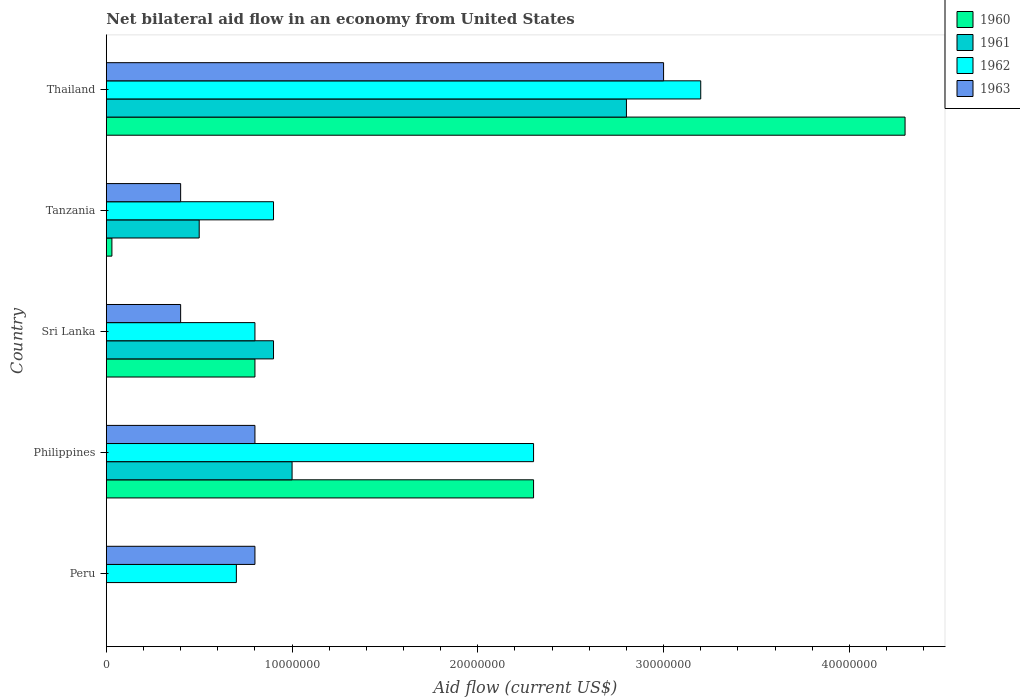How many different coloured bars are there?
Provide a succinct answer. 4. How many groups of bars are there?
Your response must be concise. 5. Are the number of bars per tick equal to the number of legend labels?
Provide a short and direct response. No. How many bars are there on the 4th tick from the top?
Provide a succinct answer. 4. What is the label of the 3rd group of bars from the top?
Ensure brevity in your answer.  Sri Lanka. What is the net bilateral aid flow in 1962 in Thailand?
Give a very brief answer. 3.20e+07. Across all countries, what is the maximum net bilateral aid flow in 1963?
Make the answer very short. 3.00e+07. Across all countries, what is the minimum net bilateral aid flow in 1961?
Provide a succinct answer. 0. In which country was the net bilateral aid flow in 1960 maximum?
Make the answer very short. Thailand. What is the total net bilateral aid flow in 1963 in the graph?
Your answer should be compact. 5.40e+07. What is the difference between the net bilateral aid flow in 1963 in Tanzania and that in Thailand?
Offer a very short reply. -2.60e+07. What is the difference between the net bilateral aid flow in 1962 in Tanzania and the net bilateral aid flow in 1960 in Sri Lanka?
Provide a short and direct response. 1.00e+06. What is the average net bilateral aid flow in 1960 per country?
Give a very brief answer. 1.49e+07. What is the difference between the net bilateral aid flow in 1962 and net bilateral aid flow in 1961 in Philippines?
Keep it short and to the point. 1.30e+07. What is the ratio of the net bilateral aid flow in 1963 in Tanzania to that in Thailand?
Make the answer very short. 0.13. Is the net bilateral aid flow in 1961 in Sri Lanka less than that in Thailand?
Give a very brief answer. Yes. Is the difference between the net bilateral aid flow in 1962 in Philippines and Thailand greater than the difference between the net bilateral aid flow in 1961 in Philippines and Thailand?
Your answer should be compact. Yes. What is the difference between the highest and the second highest net bilateral aid flow in 1961?
Your response must be concise. 1.80e+07. What is the difference between the highest and the lowest net bilateral aid flow in 1962?
Your response must be concise. 2.50e+07. Is it the case that in every country, the sum of the net bilateral aid flow in 1962 and net bilateral aid flow in 1963 is greater than the sum of net bilateral aid flow in 1961 and net bilateral aid flow in 1960?
Your answer should be compact. No. How many bars are there?
Keep it short and to the point. 18. Are all the bars in the graph horizontal?
Your answer should be compact. Yes. How many countries are there in the graph?
Your answer should be compact. 5. What is the difference between two consecutive major ticks on the X-axis?
Offer a terse response. 1.00e+07. Are the values on the major ticks of X-axis written in scientific E-notation?
Provide a short and direct response. No. Where does the legend appear in the graph?
Provide a short and direct response. Top right. How many legend labels are there?
Provide a succinct answer. 4. How are the legend labels stacked?
Offer a very short reply. Vertical. What is the title of the graph?
Provide a short and direct response. Net bilateral aid flow in an economy from United States. What is the label or title of the X-axis?
Your answer should be compact. Aid flow (current US$). What is the label or title of the Y-axis?
Your answer should be very brief. Country. What is the Aid flow (current US$) of 1960 in Peru?
Give a very brief answer. 0. What is the Aid flow (current US$) in 1962 in Peru?
Your answer should be compact. 7.00e+06. What is the Aid flow (current US$) in 1963 in Peru?
Make the answer very short. 8.00e+06. What is the Aid flow (current US$) in 1960 in Philippines?
Offer a terse response. 2.30e+07. What is the Aid flow (current US$) of 1961 in Philippines?
Give a very brief answer. 1.00e+07. What is the Aid flow (current US$) in 1962 in Philippines?
Your response must be concise. 2.30e+07. What is the Aid flow (current US$) in 1961 in Sri Lanka?
Offer a terse response. 9.00e+06. What is the Aid flow (current US$) in 1963 in Sri Lanka?
Provide a succinct answer. 4.00e+06. What is the Aid flow (current US$) of 1960 in Tanzania?
Make the answer very short. 3.00e+05. What is the Aid flow (current US$) of 1962 in Tanzania?
Provide a short and direct response. 9.00e+06. What is the Aid flow (current US$) of 1963 in Tanzania?
Your response must be concise. 4.00e+06. What is the Aid flow (current US$) in 1960 in Thailand?
Keep it short and to the point. 4.30e+07. What is the Aid flow (current US$) of 1961 in Thailand?
Offer a terse response. 2.80e+07. What is the Aid flow (current US$) in 1962 in Thailand?
Ensure brevity in your answer.  3.20e+07. What is the Aid flow (current US$) in 1963 in Thailand?
Your answer should be very brief. 3.00e+07. Across all countries, what is the maximum Aid flow (current US$) in 1960?
Provide a short and direct response. 4.30e+07. Across all countries, what is the maximum Aid flow (current US$) in 1961?
Offer a very short reply. 2.80e+07. Across all countries, what is the maximum Aid flow (current US$) in 1962?
Your answer should be very brief. 3.20e+07. Across all countries, what is the maximum Aid flow (current US$) in 1963?
Offer a very short reply. 3.00e+07. Across all countries, what is the minimum Aid flow (current US$) of 1960?
Your answer should be compact. 0. Across all countries, what is the minimum Aid flow (current US$) in 1961?
Your answer should be very brief. 0. Across all countries, what is the minimum Aid flow (current US$) of 1963?
Ensure brevity in your answer.  4.00e+06. What is the total Aid flow (current US$) in 1960 in the graph?
Make the answer very short. 7.43e+07. What is the total Aid flow (current US$) in 1961 in the graph?
Make the answer very short. 5.20e+07. What is the total Aid flow (current US$) of 1962 in the graph?
Your response must be concise. 7.90e+07. What is the total Aid flow (current US$) of 1963 in the graph?
Ensure brevity in your answer.  5.40e+07. What is the difference between the Aid flow (current US$) in 1962 in Peru and that in Philippines?
Your response must be concise. -1.60e+07. What is the difference between the Aid flow (current US$) of 1963 in Peru and that in Philippines?
Keep it short and to the point. 0. What is the difference between the Aid flow (current US$) in 1962 in Peru and that in Thailand?
Keep it short and to the point. -2.50e+07. What is the difference between the Aid flow (current US$) of 1963 in Peru and that in Thailand?
Provide a short and direct response. -2.20e+07. What is the difference between the Aid flow (current US$) in 1960 in Philippines and that in Sri Lanka?
Offer a very short reply. 1.50e+07. What is the difference between the Aid flow (current US$) of 1962 in Philippines and that in Sri Lanka?
Your answer should be very brief. 1.50e+07. What is the difference between the Aid flow (current US$) in 1963 in Philippines and that in Sri Lanka?
Make the answer very short. 4.00e+06. What is the difference between the Aid flow (current US$) in 1960 in Philippines and that in Tanzania?
Provide a short and direct response. 2.27e+07. What is the difference between the Aid flow (current US$) of 1961 in Philippines and that in Tanzania?
Provide a succinct answer. 5.00e+06. What is the difference between the Aid flow (current US$) in 1962 in Philippines and that in Tanzania?
Keep it short and to the point. 1.40e+07. What is the difference between the Aid flow (current US$) of 1960 in Philippines and that in Thailand?
Offer a very short reply. -2.00e+07. What is the difference between the Aid flow (current US$) in 1961 in Philippines and that in Thailand?
Offer a very short reply. -1.80e+07. What is the difference between the Aid flow (current US$) of 1962 in Philippines and that in Thailand?
Ensure brevity in your answer.  -9.00e+06. What is the difference between the Aid flow (current US$) in 1963 in Philippines and that in Thailand?
Provide a succinct answer. -2.20e+07. What is the difference between the Aid flow (current US$) of 1960 in Sri Lanka and that in Tanzania?
Give a very brief answer. 7.70e+06. What is the difference between the Aid flow (current US$) in 1961 in Sri Lanka and that in Tanzania?
Offer a terse response. 4.00e+06. What is the difference between the Aid flow (current US$) of 1963 in Sri Lanka and that in Tanzania?
Offer a very short reply. 0. What is the difference between the Aid flow (current US$) in 1960 in Sri Lanka and that in Thailand?
Keep it short and to the point. -3.50e+07. What is the difference between the Aid flow (current US$) in 1961 in Sri Lanka and that in Thailand?
Provide a succinct answer. -1.90e+07. What is the difference between the Aid flow (current US$) in 1962 in Sri Lanka and that in Thailand?
Your response must be concise. -2.40e+07. What is the difference between the Aid flow (current US$) in 1963 in Sri Lanka and that in Thailand?
Your answer should be compact. -2.60e+07. What is the difference between the Aid flow (current US$) in 1960 in Tanzania and that in Thailand?
Keep it short and to the point. -4.27e+07. What is the difference between the Aid flow (current US$) in 1961 in Tanzania and that in Thailand?
Provide a short and direct response. -2.30e+07. What is the difference between the Aid flow (current US$) in 1962 in Tanzania and that in Thailand?
Offer a terse response. -2.30e+07. What is the difference between the Aid flow (current US$) of 1963 in Tanzania and that in Thailand?
Make the answer very short. -2.60e+07. What is the difference between the Aid flow (current US$) of 1962 in Peru and the Aid flow (current US$) of 1963 in Philippines?
Ensure brevity in your answer.  -1.00e+06. What is the difference between the Aid flow (current US$) in 1962 in Peru and the Aid flow (current US$) in 1963 in Sri Lanka?
Your answer should be very brief. 3.00e+06. What is the difference between the Aid flow (current US$) in 1962 in Peru and the Aid flow (current US$) in 1963 in Thailand?
Your response must be concise. -2.30e+07. What is the difference between the Aid flow (current US$) in 1960 in Philippines and the Aid flow (current US$) in 1961 in Sri Lanka?
Give a very brief answer. 1.40e+07. What is the difference between the Aid flow (current US$) in 1960 in Philippines and the Aid flow (current US$) in 1962 in Sri Lanka?
Offer a terse response. 1.50e+07. What is the difference between the Aid flow (current US$) in 1960 in Philippines and the Aid flow (current US$) in 1963 in Sri Lanka?
Keep it short and to the point. 1.90e+07. What is the difference between the Aid flow (current US$) of 1961 in Philippines and the Aid flow (current US$) of 1962 in Sri Lanka?
Provide a succinct answer. 2.00e+06. What is the difference between the Aid flow (current US$) of 1962 in Philippines and the Aid flow (current US$) of 1963 in Sri Lanka?
Give a very brief answer. 1.90e+07. What is the difference between the Aid flow (current US$) of 1960 in Philippines and the Aid flow (current US$) of 1961 in Tanzania?
Your answer should be very brief. 1.80e+07. What is the difference between the Aid flow (current US$) of 1960 in Philippines and the Aid flow (current US$) of 1962 in Tanzania?
Your answer should be compact. 1.40e+07. What is the difference between the Aid flow (current US$) of 1960 in Philippines and the Aid flow (current US$) of 1963 in Tanzania?
Ensure brevity in your answer.  1.90e+07. What is the difference between the Aid flow (current US$) of 1961 in Philippines and the Aid flow (current US$) of 1962 in Tanzania?
Your answer should be very brief. 1.00e+06. What is the difference between the Aid flow (current US$) in 1962 in Philippines and the Aid flow (current US$) in 1963 in Tanzania?
Ensure brevity in your answer.  1.90e+07. What is the difference between the Aid flow (current US$) in 1960 in Philippines and the Aid flow (current US$) in 1961 in Thailand?
Make the answer very short. -5.00e+06. What is the difference between the Aid flow (current US$) of 1960 in Philippines and the Aid flow (current US$) of 1962 in Thailand?
Ensure brevity in your answer.  -9.00e+06. What is the difference between the Aid flow (current US$) of 1960 in Philippines and the Aid flow (current US$) of 1963 in Thailand?
Ensure brevity in your answer.  -7.00e+06. What is the difference between the Aid flow (current US$) of 1961 in Philippines and the Aid flow (current US$) of 1962 in Thailand?
Provide a short and direct response. -2.20e+07. What is the difference between the Aid flow (current US$) of 1961 in Philippines and the Aid flow (current US$) of 1963 in Thailand?
Ensure brevity in your answer.  -2.00e+07. What is the difference between the Aid flow (current US$) of 1962 in Philippines and the Aid flow (current US$) of 1963 in Thailand?
Keep it short and to the point. -7.00e+06. What is the difference between the Aid flow (current US$) in 1962 in Sri Lanka and the Aid flow (current US$) in 1963 in Tanzania?
Offer a very short reply. 4.00e+06. What is the difference between the Aid flow (current US$) of 1960 in Sri Lanka and the Aid flow (current US$) of 1961 in Thailand?
Keep it short and to the point. -2.00e+07. What is the difference between the Aid flow (current US$) of 1960 in Sri Lanka and the Aid flow (current US$) of 1962 in Thailand?
Keep it short and to the point. -2.40e+07. What is the difference between the Aid flow (current US$) in 1960 in Sri Lanka and the Aid flow (current US$) in 1963 in Thailand?
Offer a very short reply. -2.20e+07. What is the difference between the Aid flow (current US$) of 1961 in Sri Lanka and the Aid flow (current US$) of 1962 in Thailand?
Provide a succinct answer. -2.30e+07. What is the difference between the Aid flow (current US$) in 1961 in Sri Lanka and the Aid flow (current US$) in 1963 in Thailand?
Your response must be concise. -2.10e+07. What is the difference between the Aid flow (current US$) in 1962 in Sri Lanka and the Aid flow (current US$) in 1963 in Thailand?
Make the answer very short. -2.20e+07. What is the difference between the Aid flow (current US$) in 1960 in Tanzania and the Aid flow (current US$) in 1961 in Thailand?
Give a very brief answer. -2.77e+07. What is the difference between the Aid flow (current US$) in 1960 in Tanzania and the Aid flow (current US$) in 1962 in Thailand?
Provide a short and direct response. -3.17e+07. What is the difference between the Aid flow (current US$) of 1960 in Tanzania and the Aid flow (current US$) of 1963 in Thailand?
Your response must be concise. -2.97e+07. What is the difference between the Aid flow (current US$) of 1961 in Tanzania and the Aid flow (current US$) of 1962 in Thailand?
Make the answer very short. -2.70e+07. What is the difference between the Aid flow (current US$) in 1961 in Tanzania and the Aid flow (current US$) in 1963 in Thailand?
Your response must be concise. -2.50e+07. What is the difference between the Aid flow (current US$) of 1962 in Tanzania and the Aid flow (current US$) of 1963 in Thailand?
Give a very brief answer. -2.10e+07. What is the average Aid flow (current US$) of 1960 per country?
Give a very brief answer. 1.49e+07. What is the average Aid flow (current US$) of 1961 per country?
Offer a very short reply. 1.04e+07. What is the average Aid flow (current US$) in 1962 per country?
Give a very brief answer. 1.58e+07. What is the average Aid flow (current US$) of 1963 per country?
Offer a terse response. 1.08e+07. What is the difference between the Aid flow (current US$) in 1962 and Aid flow (current US$) in 1963 in Peru?
Make the answer very short. -1.00e+06. What is the difference between the Aid flow (current US$) of 1960 and Aid flow (current US$) of 1961 in Philippines?
Provide a short and direct response. 1.30e+07. What is the difference between the Aid flow (current US$) of 1960 and Aid flow (current US$) of 1963 in Philippines?
Give a very brief answer. 1.50e+07. What is the difference between the Aid flow (current US$) in 1961 and Aid flow (current US$) in 1962 in Philippines?
Keep it short and to the point. -1.30e+07. What is the difference between the Aid flow (current US$) of 1961 and Aid flow (current US$) of 1963 in Philippines?
Keep it short and to the point. 2.00e+06. What is the difference between the Aid flow (current US$) of 1962 and Aid flow (current US$) of 1963 in Philippines?
Give a very brief answer. 1.50e+07. What is the difference between the Aid flow (current US$) in 1960 and Aid flow (current US$) in 1961 in Sri Lanka?
Provide a short and direct response. -1.00e+06. What is the difference between the Aid flow (current US$) in 1960 and Aid flow (current US$) in 1962 in Sri Lanka?
Provide a short and direct response. 0. What is the difference between the Aid flow (current US$) of 1960 and Aid flow (current US$) of 1961 in Tanzania?
Ensure brevity in your answer.  -4.70e+06. What is the difference between the Aid flow (current US$) in 1960 and Aid flow (current US$) in 1962 in Tanzania?
Provide a short and direct response. -8.70e+06. What is the difference between the Aid flow (current US$) of 1960 and Aid flow (current US$) of 1963 in Tanzania?
Your response must be concise. -3.70e+06. What is the difference between the Aid flow (current US$) of 1961 and Aid flow (current US$) of 1962 in Tanzania?
Give a very brief answer. -4.00e+06. What is the difference between the Aid flow (current US$) of 1960 and Aid flow (current US$) of 1961 in Thailand?
Your answer should be very brief. 1.50e+07. What is the difference between the Aid flow (current US$) of 1960 and Aid flow (current US$) of 1962 in Thailand?
Keep it short and to the point. 1.10e+07. What is the difference between the Aid flow (current US$) in 1960 and Aid flow (current US$) in 1963 in Thailand?
Give a very brief answer. 1.30e+07. What is the ratio of the Aid flow (current US$) in 1962 in Peru to that in Philippines?
Ensure brevity in your answer.  0.3. What is the ratio of the Aid flow (current US$) in 1963 in Peru to that in Philippines?
Offer a terse response. 1. What is the ratio of the Aid flow (current US$) of 1962 in Peru to that in Sri Lanka?
Provide a succinct answer. 0.88. What is the ratio of the Aid flow (current US$) of 1962 in Peru to that in Tanzania?
Ensure brevity in your answer.  0.78. What is the ratio of the Aid flow (current US$) in 1962 in Peru to that in Thailand?
Provide a succinct answer. 0.22. What is the ratio of the Aid flow (current US$) of 1963 in Peru to that in Thailand?
Offer a very short reply. 0.27. What is the ratio of the Aid flow (current US$) in 1960 in Philippines to that in Sri Lanka?
Provide a succinct answer. 2.88. What is the ratio of the Aid flow (current US$) of 1961 in Philippines to that in Sri Lanka?
Keep it short and to the point. 1.11. What is the ratio of the Aid flow (current US$) in 1962 in Philippines to that in Sri Lanka?
Provide a short and direct response. 2.88. What is the ratio of the Aid flow (current US$) of 1960 in Philippines to that in Tanzania?
Offer a very short reply. 76.67. What is the ratio of the Aid flow (current US$) of 1962 in Philippines to that in Tanzania?
Your answer should be compact. 2.56. What is the ratio of the Aid flow (current US$) in 1963 in Philippines to that in Tanzania?
Offer a terse response. 2. What is the ratio of the Aid flow (current US$) of 1960 in Philippines to that in Thailand?
Keep it short and to the point. 0.53. What is the ratio of the Aid flow (current US$) in 1961 in Philippines to that in Thailand?
Make the answer very short. 0.36. What is the ratio of the Aid flow (current US$) in 1962 in Philippines to that in Thailand?
Offer a terse response. 0.72. What is the ratio of the Aid flow (current US$) in 1963 in Philippines to that in Thailand?
Keep it short and to the point. 0.27. What is the ratio of the Aid flow (current US$) in 1960 in Sri Lanka to that in Tanzania?
Offer a terse response. 26.67. What is the ratio of the Aid flow (current US$) of 1961 in Sri Lanka to that in Tanzania?
Your response must be concise. 1.8. What is the ratio of the Aid flow (current US$) in 1960 in Sri Lanka to that in Thailand?
Provide a short and direct response. 0.19. What is the ratio of the Aid flow (current US$) in 1961 in Sri Lanka to that in Thailand?
Make the answer very short. 0.32. What is the ratio of the Aid flow (current US$) in 1962 in Sri Lanka to that in Thailand?
Your response must be concise. 0.25. What is the ratio of the Aid flow (current US$) in 1963 in Sri Lanka to that in Thailand?
Your answer should be very brief. 0.13. What is the ratio of the Aid flow (current US$) of 1960 in Tanzania to that in Thailand?
Give a very brief answer. 0.01. What is the ratio of the Aid flow (current US$) of 1961 in Tanzania to that in Thailand?
Offer a very short reply. 0.18. What is the ratio of the Aid flow (current US$) of 1962 in Tanzania to that in Thailand?
Offer a very short reply. 0.28. What is the ratio of the Aid flow (current US$) in 1963 in Tanzania to that in Thailand?
Provide a short and direct response. 0.13. What is the difference between the highest and the second highest Aid flow (current US$) of 1960?
Your answer should be very brief. 2.00e+07. What is the difference between the highest and the second highest Aid flow (current US$) of 1961?
Your answer should be compact. 1.80e+07. What is the difference between the highest and the second highest Aid flow (current US$) of 1962?
Give a very brief answer. 9.00e+06. What is the difference between the highest and the second highest Aid flow (current US$) in 1963?
Your answer should be very brief. 2.20e+07. What is the difference between the highest and the lowest Aid flow (current US$) in 1960?
Your answer should be very brief. 4.30e+07. What is the difference between the highest and the lowest Aid flow (current US$) in 1961?
Your answer should be very brief. 2.80e+07. What is the difference between the highest and the lowest Aid flow (current US$) of 1962?
Your response must be concise. 2.50e+07. What is the difference between the highest and the lowest Aid flow (current US$) in 1963?
Your response must be concise. 2.60e+07. 